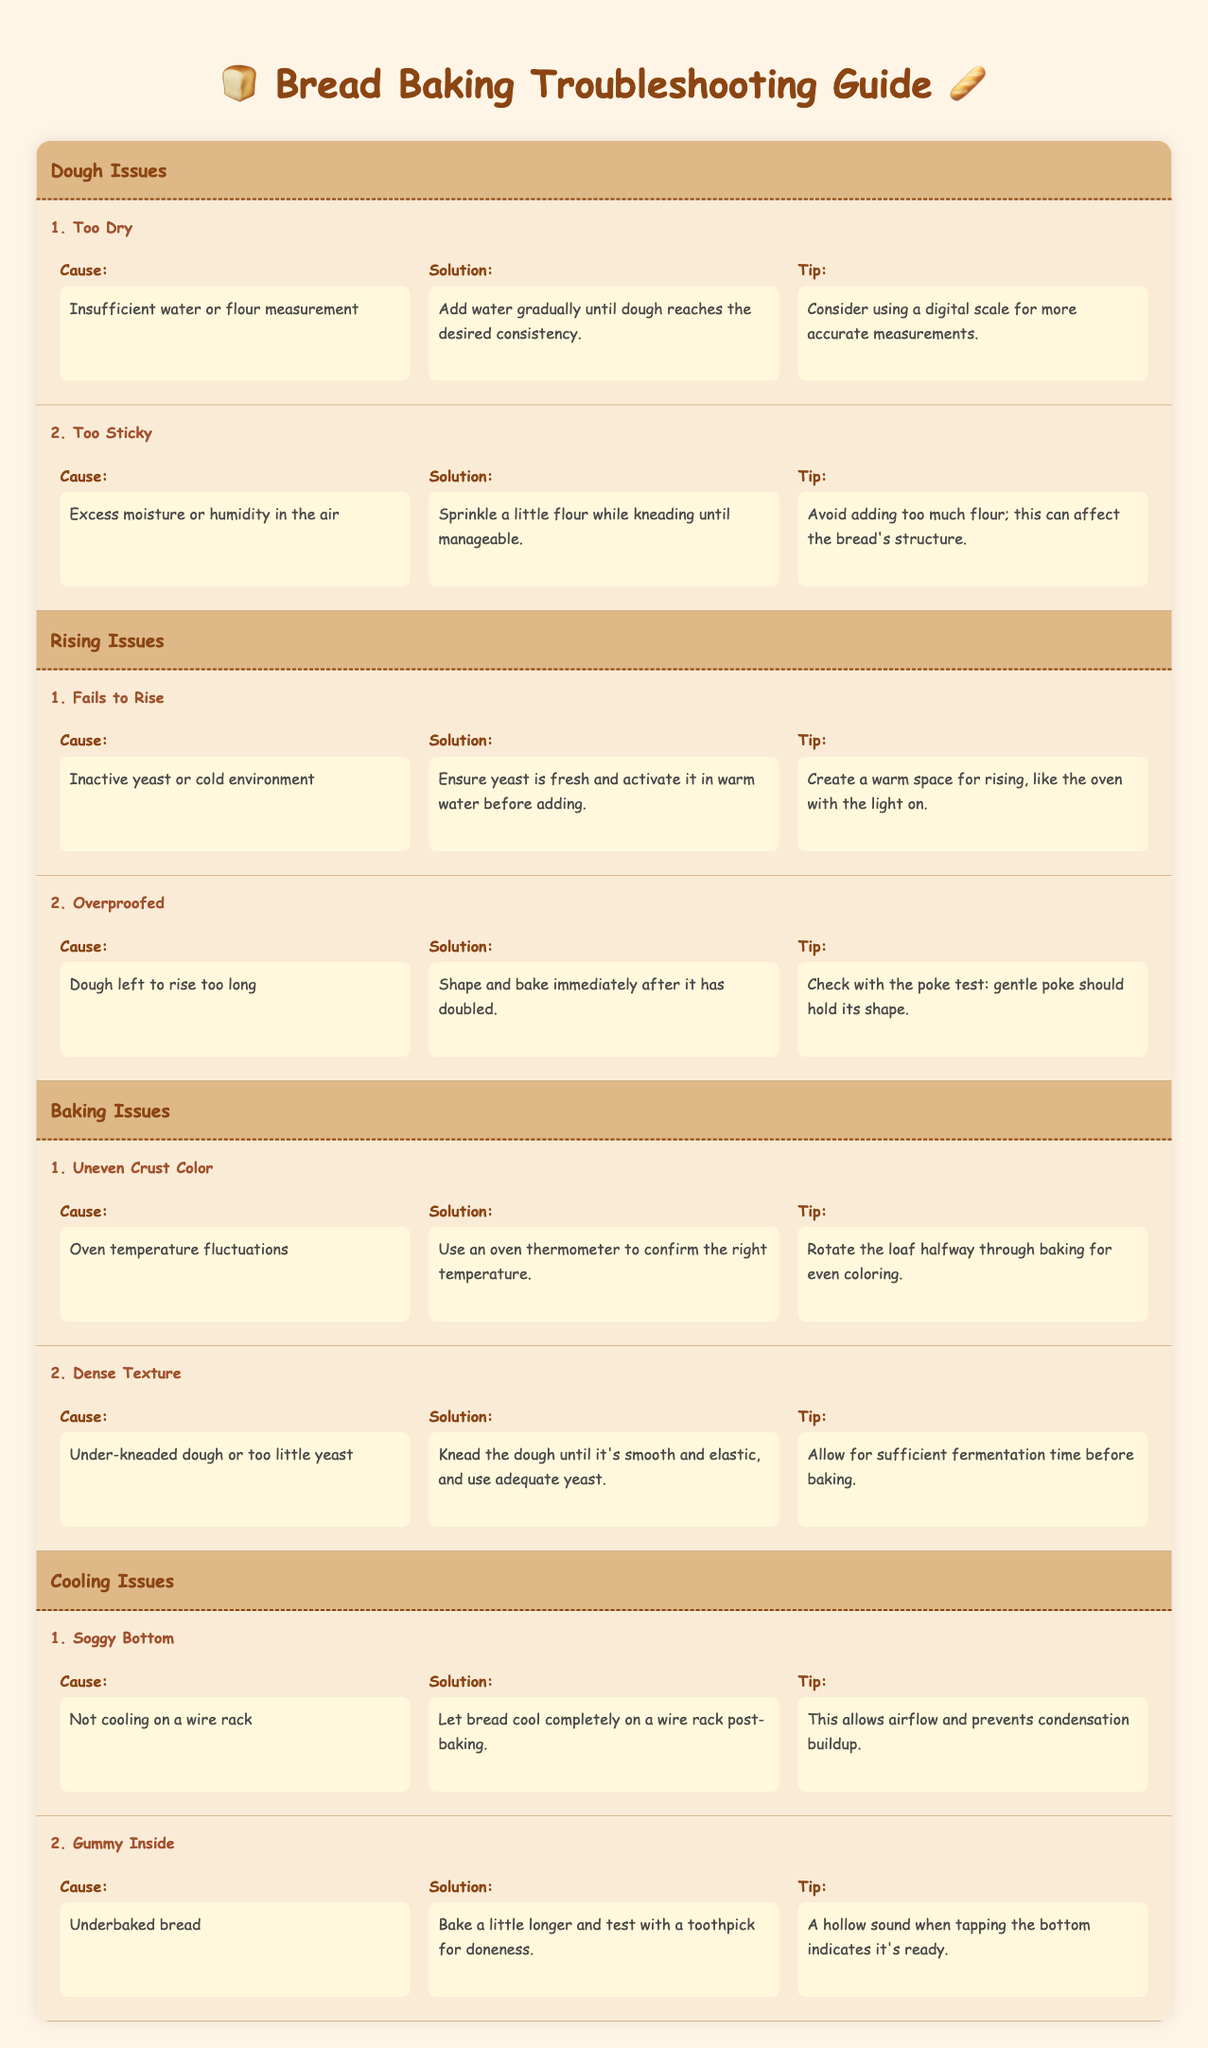What is the solution for "Too Dry" dough? The solution listed in the table is to add water gradually until the dough reaches the desired consistency.
Answer: Add water gradually until dough reaches desired consistency What is the cause of "Gummy Inside" bread? According to the table, the cause of gummy inside bread is that it is underbaked.
Answer: Underbaked bread What tip is provided for addressing "Soggy Bottom"? The tip for addressing soggy bottom is to let the bread cool completely on a wire rack post-baking.
Answer: Let bread cool completely on a wire rack Is it true that dough can be too sticky because of excess humidity in the air? Yes, the table states that excess moisture or humidity in the air is a cause for too sticky dough.
Answer: Yes What should you do if your bread has uneven crust color? The solution is to use an oven thermometer to confirm the right temperature. Additionally, you should rotate the loaf halfway through baking for even coloring.
Answer: Use an oven thermometer and rotate the loaf What steps would you take if your bread fails to rise? First, ensure the yeast is fresh. Next, activate it in warm water before adding it to the dough. Finally, create a warm space for rising like using the oven with the light on.
Answer: Ensure yeast is fresh and create a warm space for rising What is the difference between the causes of "Fails to Rise" and "Overproofed"? "Fails to Rise" is caused by inactive yeast or a cold environment, while "Overproofed" is due to the dough being left to rise too long.
Answer: Different causes: inactive yeast vs. too long rising What is the combined effect if too little yeast and under-kneaded dough are present? If both issues occur, the bread will have a dense texture and may not rise sufficiently, making it heavy and unappealing.
Answer: Dense texture as the effect Based on the provided issues, what common step can help both "Too Dry" and "Too Sticky" doughs? A common productive step is ensuring accurate measurements of water and flour, which can positively impact the dough consistency in both cases.
Answer: Accurate measurements of water and flour 